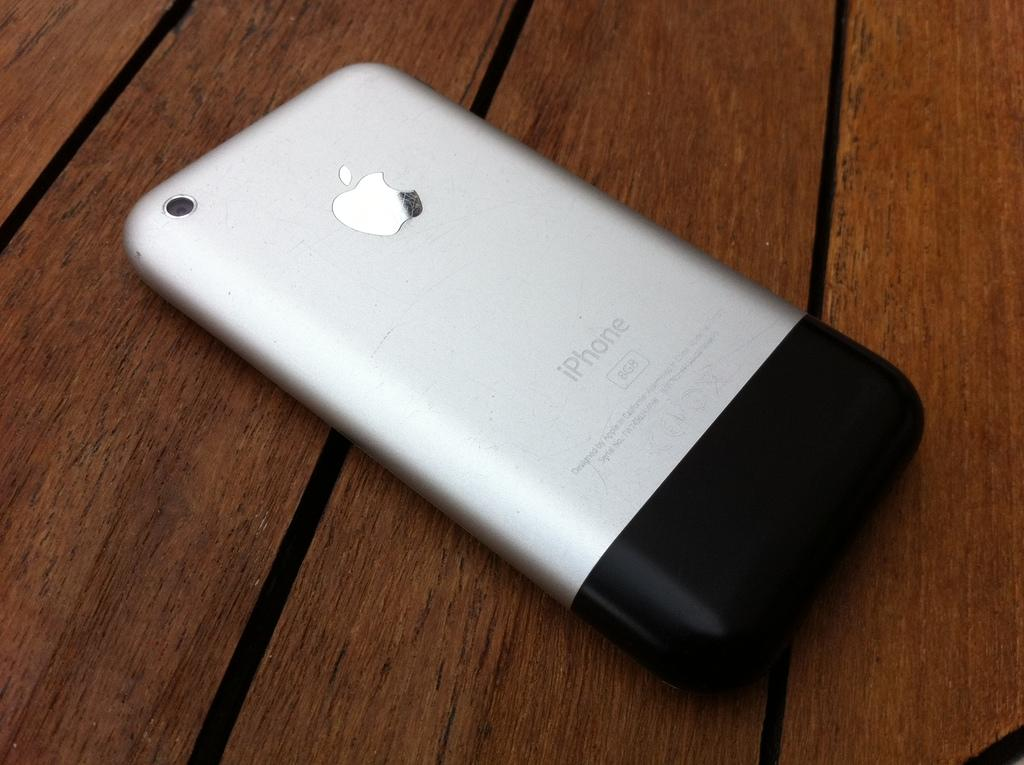Provide a one-sentence caption for the provided image. The iphone is laying upside down on the wood table. 